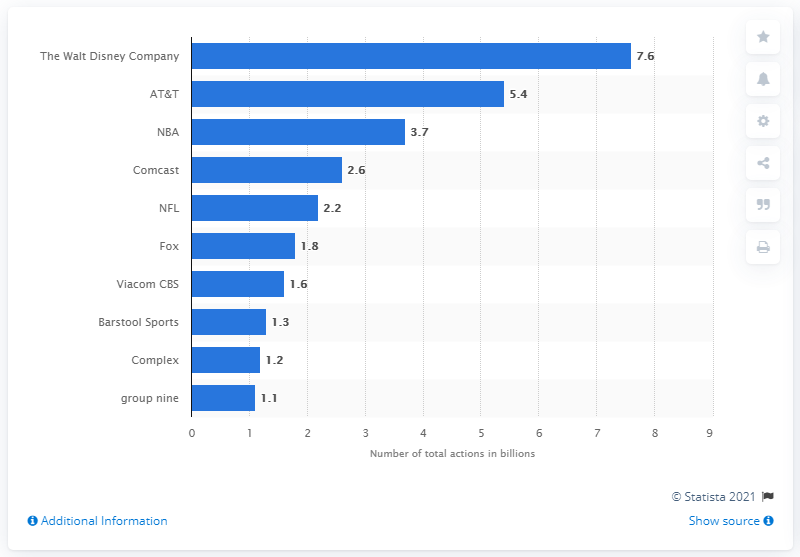List a handful of essential elements in this visual. In 2020, AT&T was the second most popular media publishing company in the United States. The Walt Disney Company was the most popular media publishing company in the United States in 2020. 